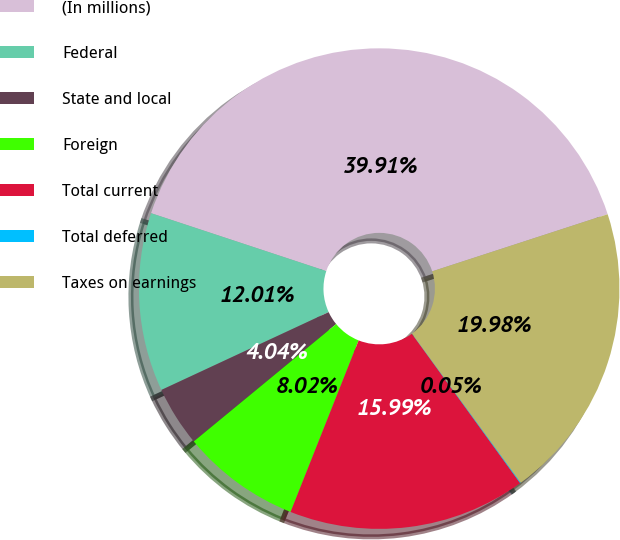Convert chart to OTSL. <chart><loc_0><loc_0><loc_500><loc_500><pie_chart><fcel>(In millions)<fcel>Federal<fcel>State and local<fcel>Foreign<fcel>Total current<fcel>Total deferred<fcel>Taxes on earnings<nl><fcel>39.91%<fcel>12.01%<fcel>4.04%<fcel>8.02%<fcel>15.99%<fcel>0.05%<fcel>19.98%<nl></chart> 